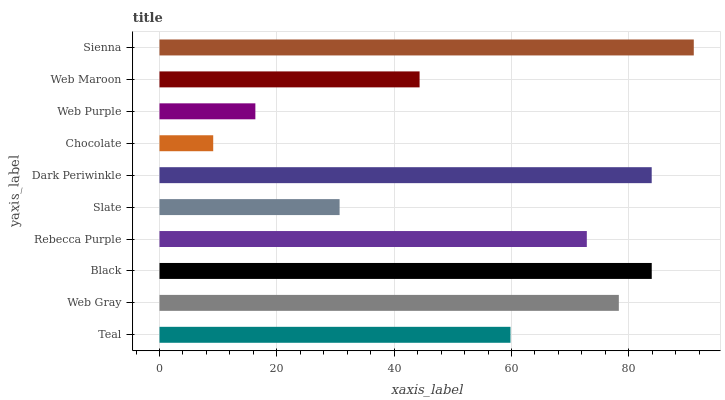Is Chocolate the minimum?
Answer yes or no. Yes. Is Sienna the maximum?
Answer yes or no. Yes. Is Web Gray the minimum?
Answer yes or no. No. Is Web Gray the maximum?
Answer yes or no. No. Is Web Gray greater than Teal?
Answer yes or no. Yes. Is Teal less than Web Gray?
Answer yes or no. Yes. Is Teal greater than Web Gray?
Answer yes or no. No. Is Web Gray less than Teal?
Answer yes or no. No. Is Rebecca Purple the high median?
Answer yes or no. Yes. Is Teal the low median?
Answer yes or no. Yes. Is Chocolate the high median?
Answer yes or no. No. Is Sienna the low median?
Answer yes or no. No. 